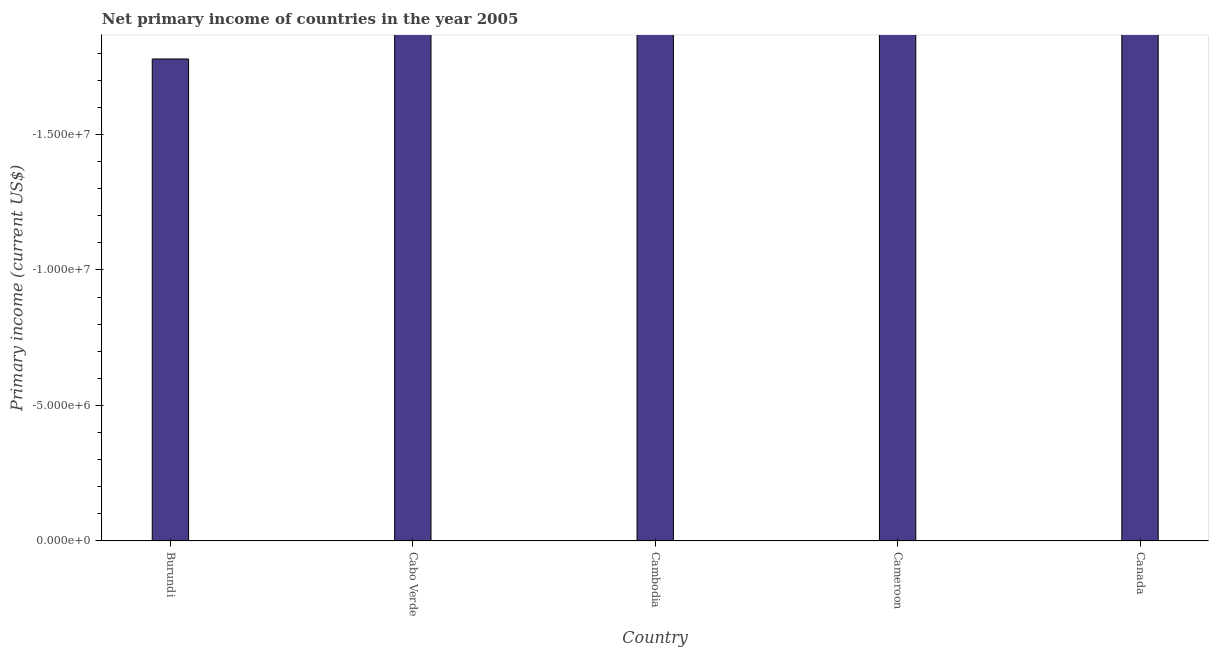What is the title of the graph?
Ensure brevity in your answer.  Net primary income of countries in the year 2005. What is the label or title of the X-axis?
Offer a terse response. Country. What is the label or title of the Y-axis?
Your answer should be very brief. Primary income (current US$). What is the amount of primary income in Burundi?
Keep it short and to the point. 0. Across all countries, what is the minimum amount of primary income?
Your answer should be compact. 0. What is the sum of the amount of primary income?
Keep it short and to the point. 0. In how many countries, is the amount of primary income greater than -8000000 US$?
Offer a very short reply. 0. In how many countries, is the amount of primary income greater than the average amount of primary income taken over all countries?
Provide a short and direct response. 0. How many bars are there?
Offer a very short reply. 0. Are all the bars in the graph horizontal?
Provide a succinct answer. No. Are the values on the major ticks of Y-axis written in scientific E-notation?
Provide a short and direct response. Yes. What is the Primary income (current US$) of Cameroon?
Your response must be concise. 0. 